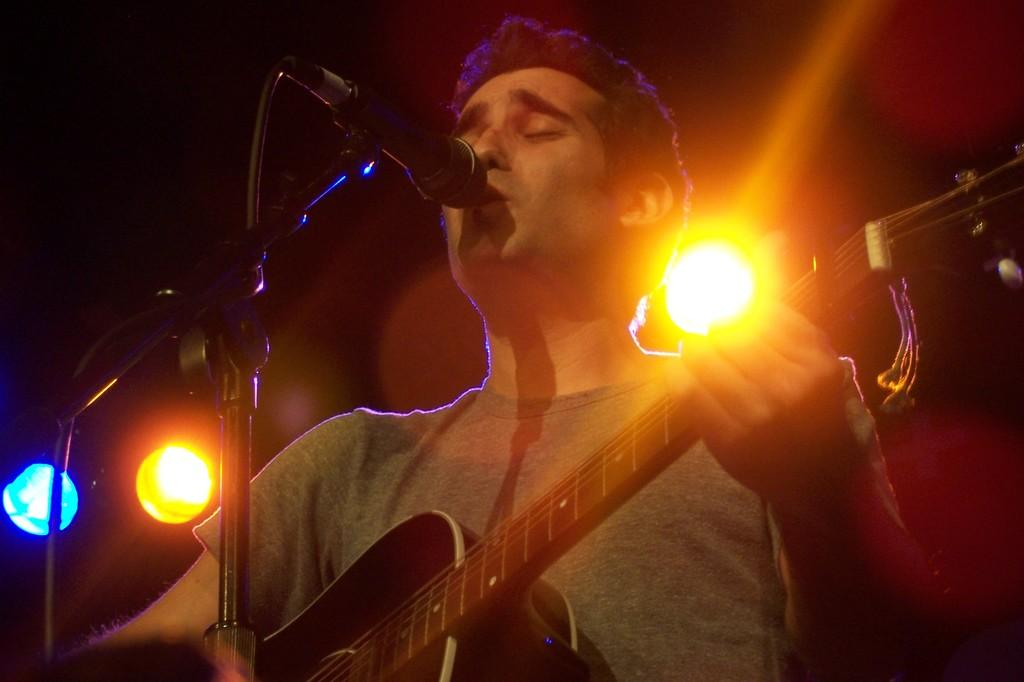What is the man in the image doing? The man is singing in the image. What object is the man holding while singing? The man is holding a microphone. What musical instrument is the man playing? The man is playing a guitar. What type of plantation can be seen in the background of the image? There is no plantation present in the image; it features a man singing while holding a microphone and playing a guitar. 